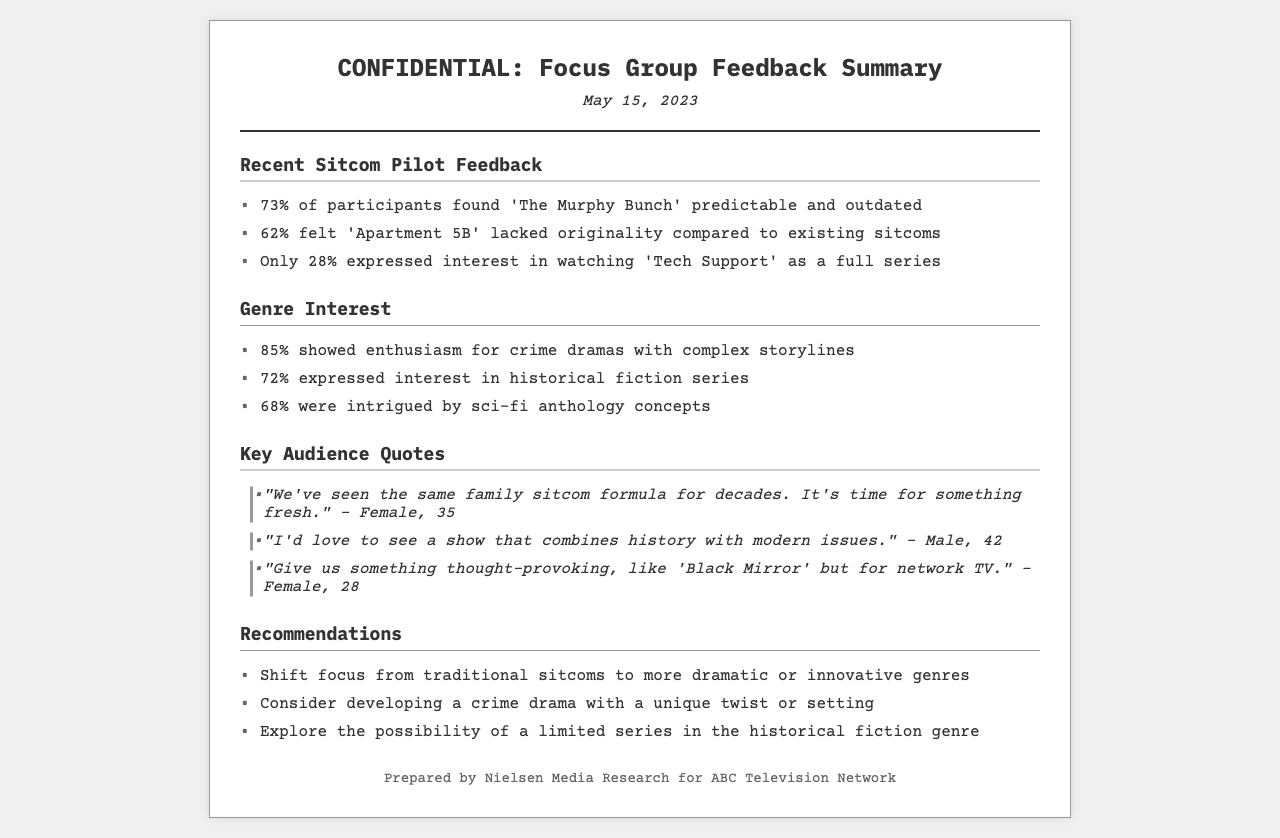What percentage of participants found 'The Murphy Bunch' predictable? The document states that 73% of participants found 'The Murphy Bunch' predictable and outdated.
Answer: 73% What genre had the highest interest among focus group participants? According to the feedback, 85% showed enthusiasm for crime dramas with complex storylines, which is the highest percentage among the genres listed.
Answer: crime dramas How many participants expressed interest in watching 'Tech Support' as a full series? The document mentions that only 28% expressed interest in watching 'Tech Support' as a full series.
Answer: 28% What did 68% of participants express interest in? The document indicates that 68% were intrigued by sci-fi anthology concepts, reflecting their interest in this genre.
Answer: sci-fi anthology concepts What unique recommendation is made for a crime drama? The document suggests considering developing a crime drama with a unique twist or setting, highlighting the need for innovation in this genre.
Answer: unique twist or setting What was a common audience sentiment towards family sitcoms? A key audience quote states that many feel we have seen the same family sitcom formula for decades, suggesting a desire for something different.
Answer: fresh What percentage of focus group participants found 'Apartment 5B' lacking originality? The feedback summary indicates that 62% felt 'Apartment 5B' lacked originality compared to existing sitcoms.
Answer: 62% Who prepared the focus group feedback summary? The document identifies Nielsen Media Research as the preparer of the focus group feedback summary for ABC Television Network.
Answer: Nielsen Media Research 